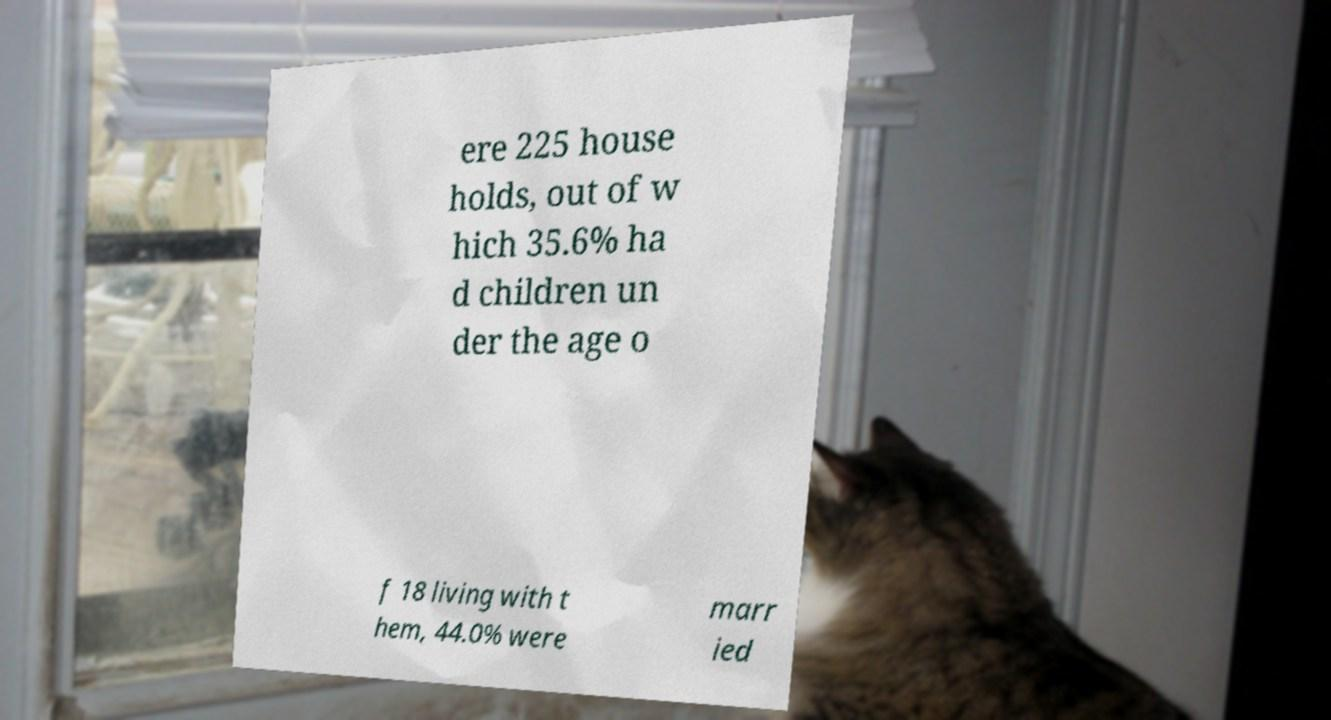Could you assist in decoding the text presented in this image and type it out clearly? ere 225 house holds, out of w hich 35.6% ha d children un der the age o f 18 living with t hem, 44.0% were marr ied 